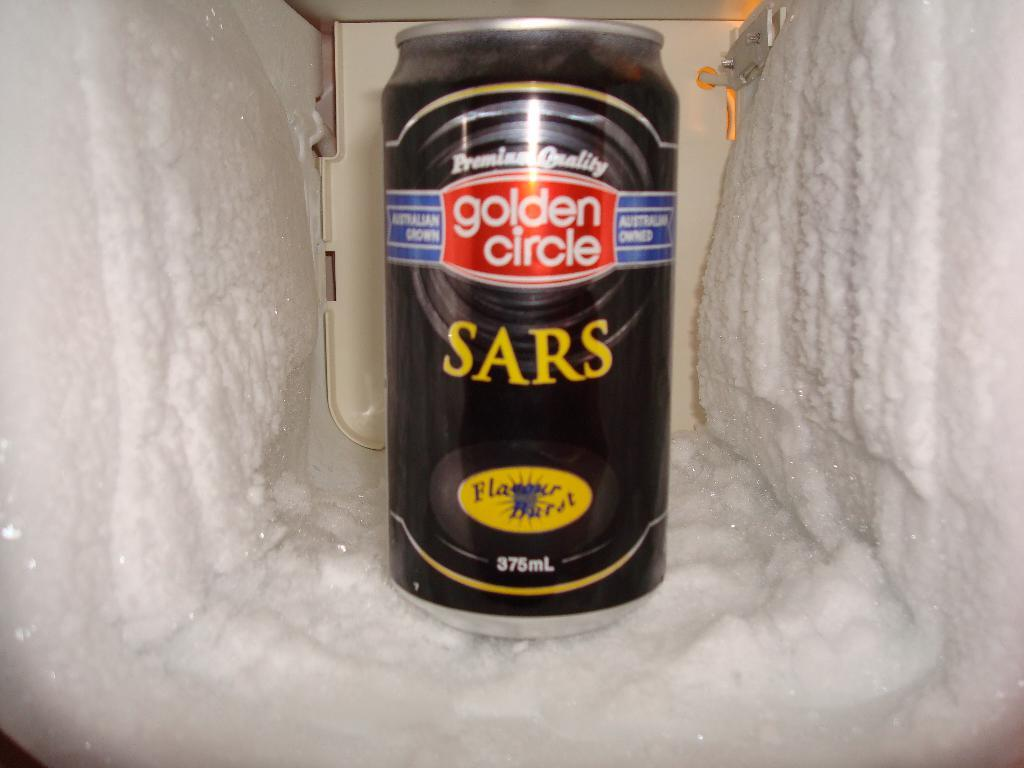Provide a one-sentence caption for the provided image. A Golden Circle branded can sits in a hole of frozen crust. 